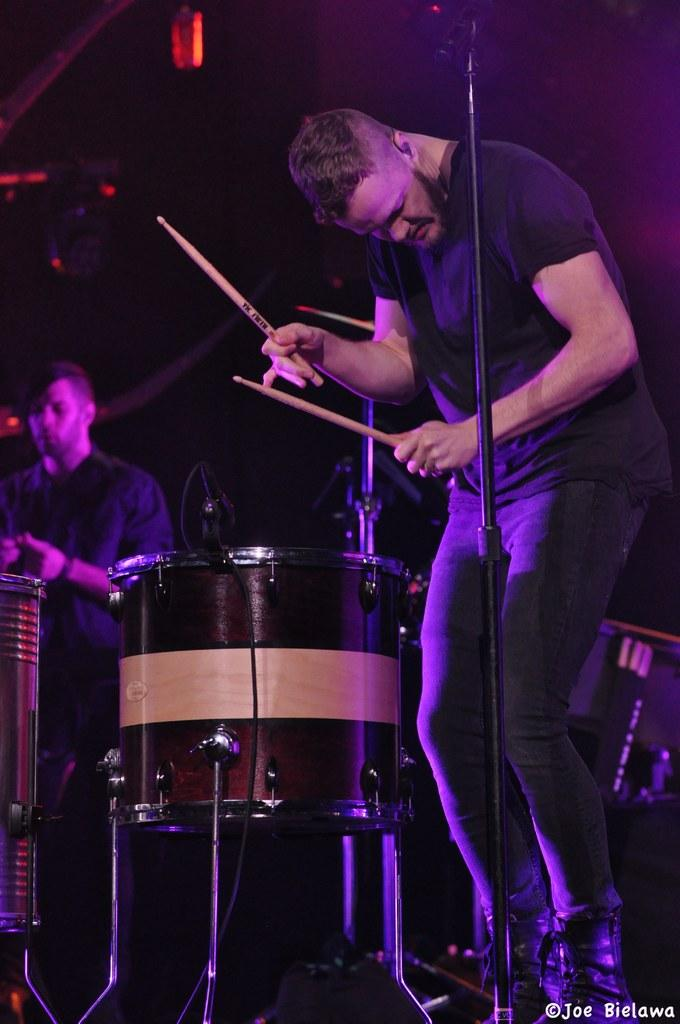How many people are in the image? There are two persons in the image. Can you describe the position of one of the persons? One person is standing in front. What is the person in front holding? The person in front is holding two sticks. What else can be seen in the image besides the people? There are musical instruments in the image. What is the color of the background in the image? The background of the image is dark. What type of furniture can be seen in the image? There is no furniture present in the image. What reward is the person in front receiving for holding the two sticks? There is no indication in the image that the person is receiving a reward for holding the two sticks. 